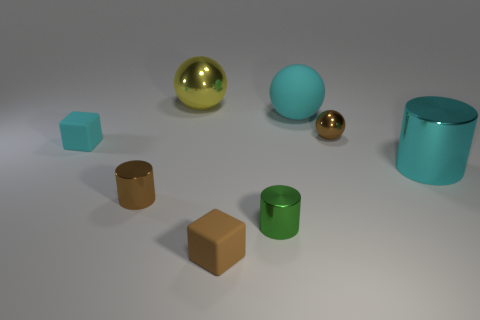Subtract all shiny balls. How many balls are left? 1 Add 1 big metal things. How many objects exist? 9 Subtract all cyan spheres. How many spheres are left? 2 Add 7 rubber objects. How many rubber objects exist? 10 Subtract 1 brown cubes. How many objects are left? 7 Subtract all cylinders. How many objects are left? 5 Subtract all blue blocks. Subtract all brown balls. How many blocks are left? 2 Subtract all cyan cubes. Subtract all brown metallic balls. How many objects are left? 6 Add 1 cyan metal things. How many cyan metal things are left? 2 